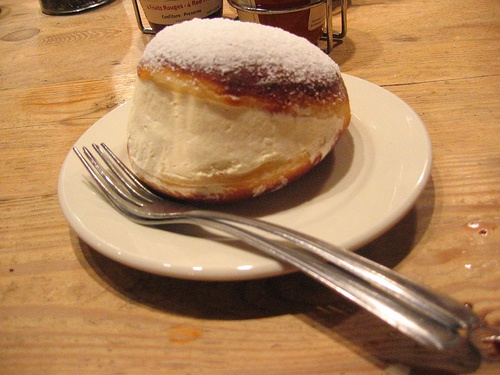Describe the objects in this image and their specific colors. I can see dining table in tan and black tones, cake in tan and brown tones, and fork in tan, gray, and maroon tones in this image. 